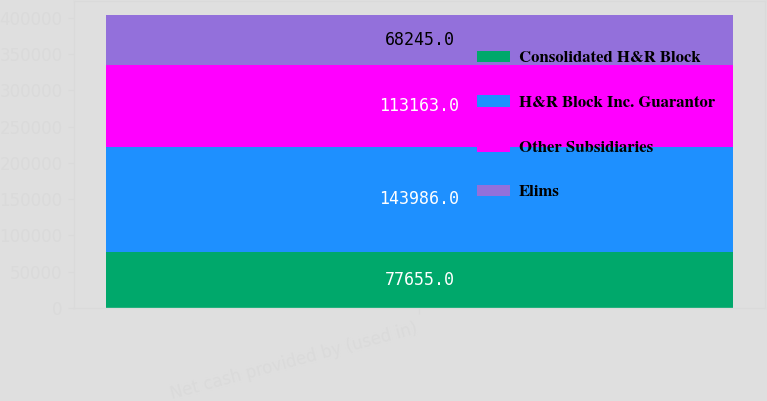Convert chart. <chart><loc_0><loc_0><loc_500><loc_500><stacked_bar_chart><ecel><fcel>Net cash provided by (used in)<nl><fcel>Consolidated H&R Block<fcel>77655<nl><fcel>H&R Block Inc. Guarantor<fcel>143986<nl><fcel>Other Subsidiaries<fcel>113163<nl><fcel>Elims<fcel>68245<nl></chart> 